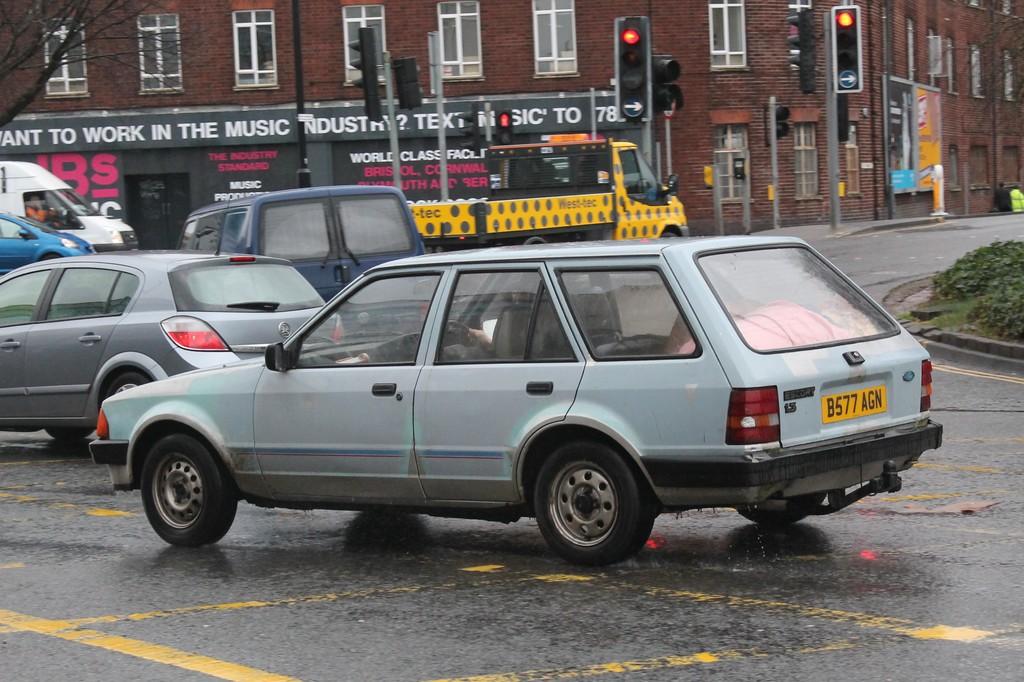What is the license plate of this station wagon?
Provide a succinct answer. B577 agn. 